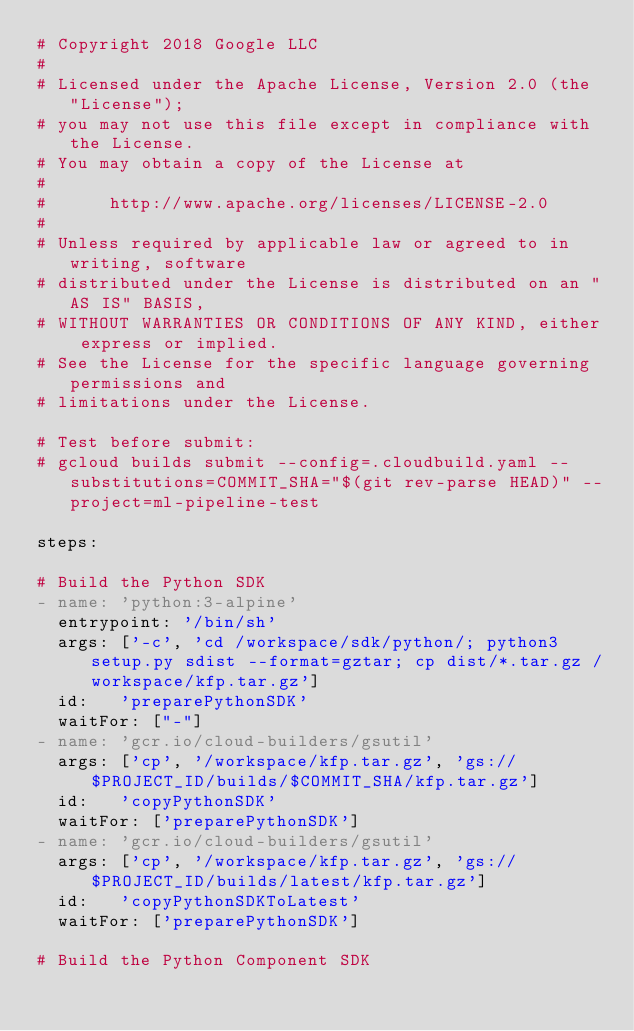<code> <loc_0><loc_0><loc_500><loc_500><_YAML_># Copyright 2018 Google LLC
#
# Licensed under the Apache License, Version 2.0 (the "License");
# you may not use this file except in compliance with the License.
# You may obtain a copy of the License at
#
#      http://www.apache.org/licenses/LICENSE-2.0
#
# Unless required by applicable law or agreed to in writing, software
# distributed under the License is distributed on an "AS IS" BASIS,
# WITHOUT WARRANTIES OR CONDITIONS OF ANY KIND, either express or implied.
# See the License for the specific language governing permissions and
# limitations under the License.

# Test before submit:
# gcloud builds submit --config=.cloudbuild.yaml --substitutions=COMMIT_SHA="$(git rev-parse HEAD)" --project=ml-pipeline-test

steps:

# Build the Python SDK
- name: 'python:3-alpine'
  entrypoint: '/bin/sh'
  args: ['-c', 'cd /workspace/sdk/python/; python3 setup.py sdist --format=gztar; cp dist/*.tar.gz /workspace/kfp.tar.gz']
  id:   'preparePythonSDK'
  waitFor: ["-"]
- name: 'gcr.io/cloud-builders/gsutil'
  args: ['cp', '/workspace/kfp.tar.gz', 'gs://$PROJECT_ID/builds/$COMMIT_SHA/kfp.tar.gz']
  id:   'copyPythonSDK'
  waitFor: ['preparePythonSDK']
- name: 'gcr.io/cloud-builders/gsutil'
  args: ['cp', '/workspace/kfp.tar.gz', 'gs://$PROJECT_ID/builds/latest/kfp.tar.gz']
  id:   'copyPythonSDKToLatest'
  waitFor: ['preparePythonSDK']

# Build the Python Component SDK</code> 